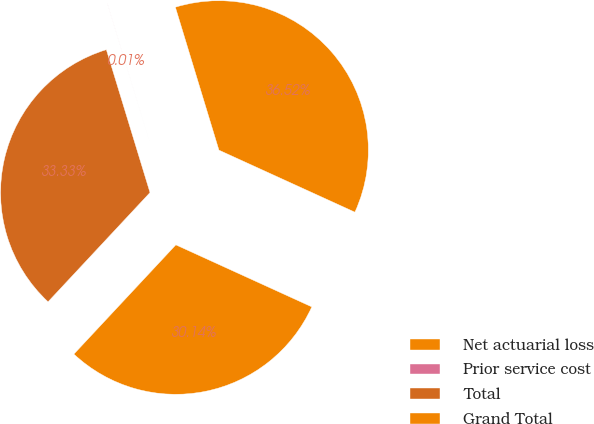<chart> <loc_0><loc_0><loc_500><loc_500><pie_chart><fcel>Net actuarial loss<fcel>Prior service cost<fcel>Total<fcel>Grand Total<nl><fcel>36.52%<fcel>0.01%<fcel>33.33%<fcel>30.14%<nl></chart> 